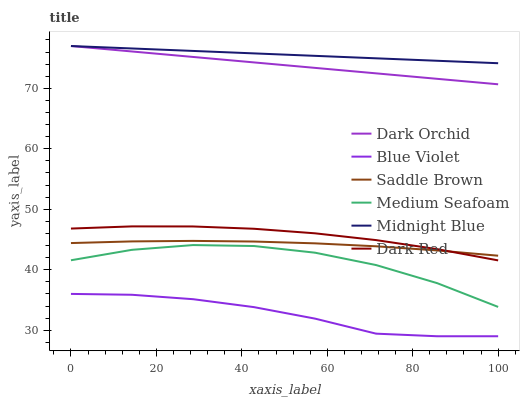Does Blue Violet have the minimum area under the curve?
Answer yes or no. Yes. Does Midnight Blue have the maximum area under the curve?
Answer yes or no. Yes. Does Dark Red have the minimum area under the curve?
Answer yes or no. No. Does Dark Red have the maximum area under the curve?
Answer yes or no. No. Is Midnight Blue the smoothest?
Answer yes or no. Yes. Is Medium Seafoam the roughest?
Answer yes or no. Yes. Is Dark Red the smoothest?
Answer yes or no. No. Is Dark Red the roughest?
Answer yes or no. No. Does Blue Violet have the lowest value?
Answer yes or no. Yes. Does Dark Red have the lowest value?
Answer yes or no. No. Does Dark Orchid have the highest value?
Answer yes or no. Yes. Does Dark Red have the highest value?
Answer yes or no. No. Is Blue Violet less than Saddle Brown?
Answer yes or no. Yes. Is Dark Orchid greater than Blue Violet?
Answer yes or no. Yes. Does Saddle Brown intersect Dark Red?
Answer yes or no. Yes. Is Saddle Brown less than Dark Red?
Answer yes or no. No. Is Saddle Brown greater than Dark Red?
Answer yes or no. No. Does Blue Violet intersect Saddle Brown?
Answer yes or no. No. 